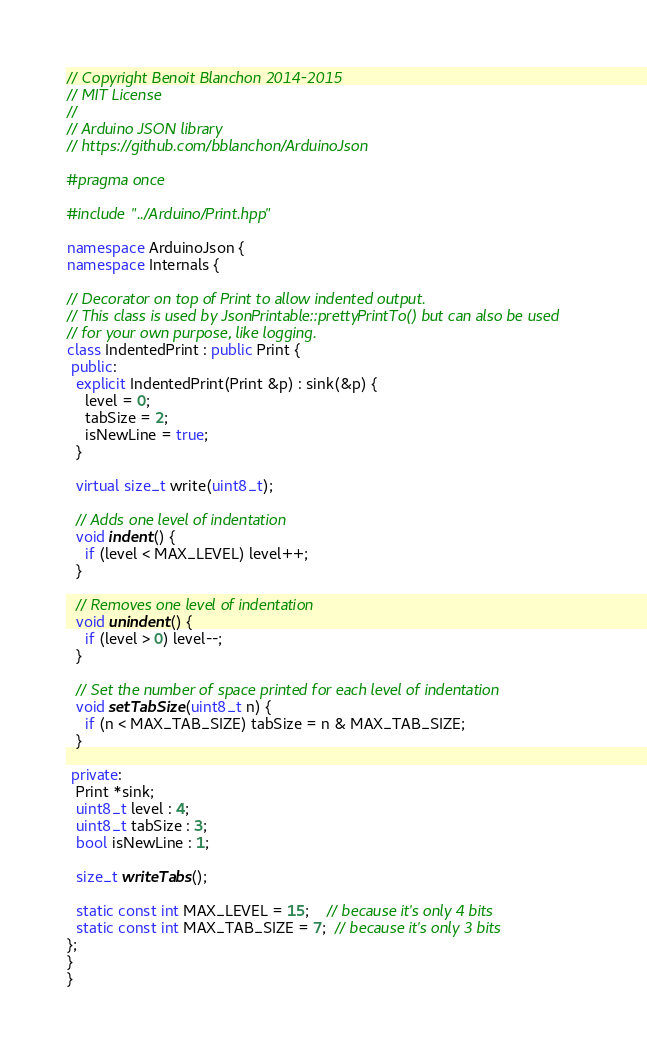<code> <loc_0><loc_0><loc_500><loc_500><_C++_>// Copyright Benoit Blanchon 2014-2015
// MIT License
//
// Arduino JSON library
// https://github.com/bblanchon/ArduinoJson

#pragma once

#include "../Arduino/Print.hpp"

namespace ArduinoJson {
namespace Internals {

// Decorator on top of Print to allow indented output.
// This class is used by JsonPrintable::prettyPrintTo() but can also be used
// for your own purpose, like logging.
class IndentedPrint : public Print {
 public:
  explicit IndentedPrint(Print &p) : sink(&p) {
    level = 0;
    tabSize = 2;
    isNewLine = true;
  }

  virtual size_t write(uint8_t);

  // Adds one level of indentation
  void indent() {
    if (level < MAX_LEVEL) level++;
  }

  // Removes one level of indentation
  void unindent() {
    if (level > 0) level--;
  }

  // Set the number of space printed for each level of indentation
  void setTabSize(uint8_t n) {
    if (n < MAX_TAB_SIZE) tabSize = n & MAX_TAB_SIZE;
  }

 private:
  Print *sink;
  uint8_t level : 4;
  uint8_t tabSize : 3;
  bool isNewLine : 1;

  size_t writeTabs();

  static const int MAX_LEVEL = 15;    // because it's only 4 bits
  static const int MAX_TAB_SIZE = 7;  // because it's only 3 bits
};
}
}
</code> 